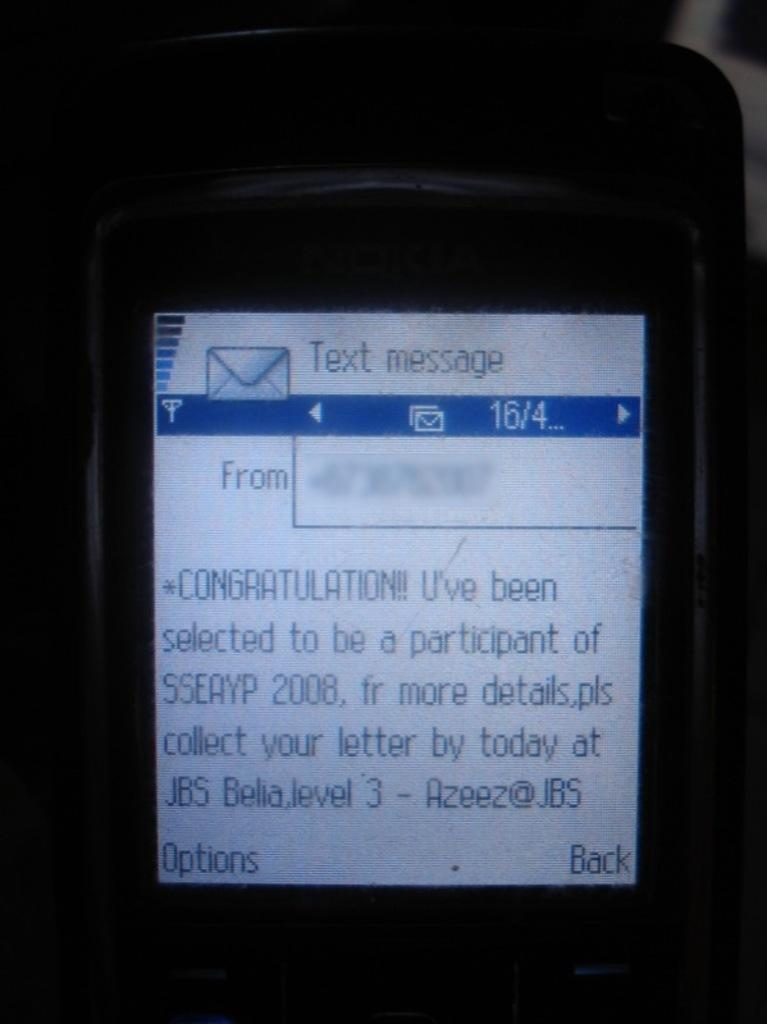<image>
Summarize the visual content of the image. A zoomed in cellphone with the text on the screen talking about participation in a contest. 